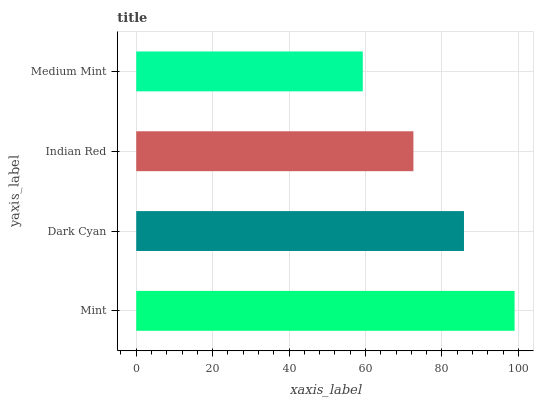Is Medium Mint the minimum?
Answer yes or no. Yes. Is Mint the maximum?
Answer yes or no. Yes. Is Dark Cyan the minimum?
Answer yes or no. No. Is Dark Cyan the maximum?
Answer yes or no. No. Is Mint greater than Dark Cyan?
Answer yes or no. Yes. Is Dark Cyan less than Mint?
Answer yes or no. Yes. Is Dark Cyan greater than Mint?
Answer yes or no. No. Is Mint less than Dark Cyan?
Answer yes or no. No. Is Dark Cyan the high median?
Answer yes or no. Yes. Is Indian Red the low median?
Answer yes or no. Yes. Is Indian Red the high median?
Answer yes or no. No. Is Medium Mint the low median?
Answer yes or no. No. 